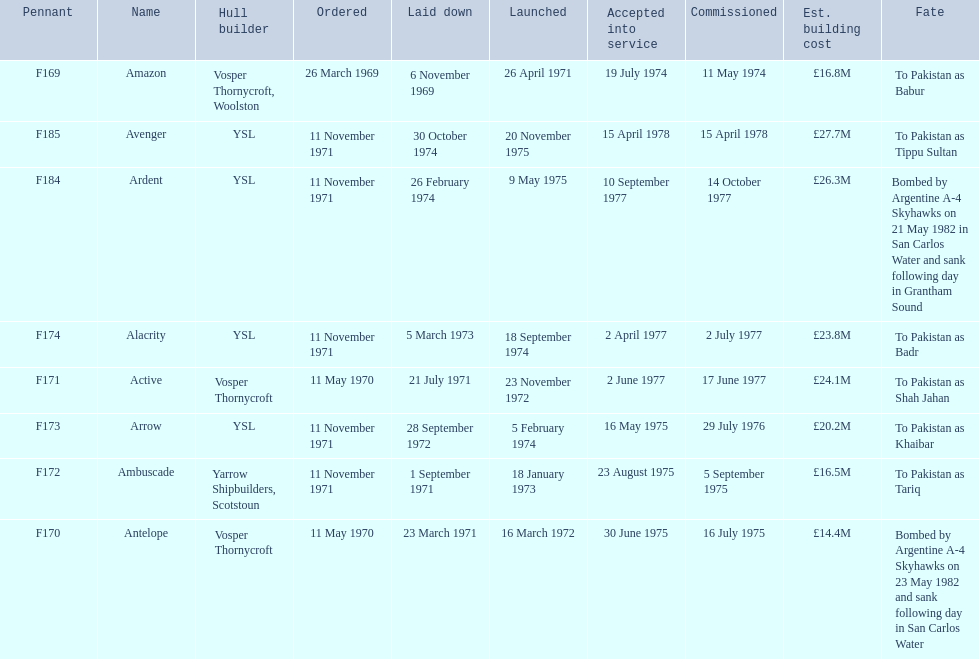Which type 21 frigate ships were to be built by ysl in the 1970s? Arrow, Alacrity, Ardent, Avenger. Could you parse the entire table? {'header': ['Pennant', 'Name', 'Hull builder', 'Ordered', 'Laid down', 'Launched', 'Accepted into service', 'Commissioned', 'Est. building cost', 'Fate'], 'rows': [['F169', 'Amazon', 'Vosper Thornycroft, Woolston', '26 March 1969', '6 November 1969', '26 April 1971', '19 July 1974', '11 May 1974', '£16.8M', 'To Pakistan as Babur'], ['F185', 'Avenger', 'YSL', '11 November 1971', '30 October 1974', '20 November 1975', '15 April 1978', '15 April 1978', '£27.7M', 'To Pakistan as Tippu Sultan'], ['F184', 'Ardent', 'YSL', '11 November 1971', '26 February 1974', '9 May 1975', '10 September 1977', '14 October 1977', '£26.3M', 'Bombed by Argentine A-4 Skyhawks on 21 May 1982 in San Carlos Water and sank following day in Grantham Sound'], ['F174', 'Alacrity', 'YSL', '11 November 1971', '5 March 1973', '18 September 1974', '2 April 1977', '2 July 1977', '£23.8M', 'To Pakistan as Badr'], ['F171', 'Active', 'Vosper Thornycroft', '11 May 1970', '21 July 1971', '23 November 1972', '2 June 1977', '17 June 1977', '£24.1M', 'To Pakistan as Shah Jahan'], ['F173', 'Arrow', 'YSL', '11 November 1971', '28 September 1972', '5 February 1974', '16 May 1975', '29 July 1976', '£20.2M', 'To Pakistan as Khaibar'], ['F172', 'Ambuscade', 'Yarrow Shipbuilders, Scotstoun', '11 November 1971', '1 September 1971', '18 January 1973', '23 August 1975', '5 September 1975', '£16.5M', 'To Pakistan as Tariq'], ['F170', 'Antelope', 'Vosper Thornycroft', '11 May 1970', '23 March 1971', '16 March 1972', '30 June 1975', '16 July 1975', '£14.4M', 'Bombed by Argentine A-4 Skyhawks on 23 May 1982 and sank following day in San Carlos Water']]} Of these ships, which one had the highest estimated building cost? Avenger. 